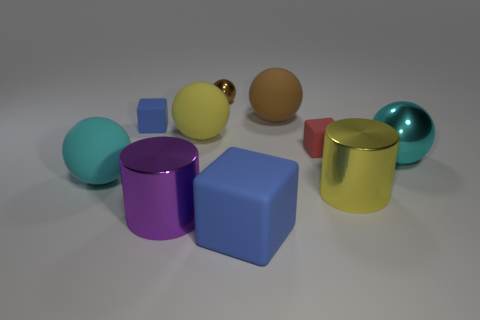There is a cyan object that is right of the cyan ball that is on the left side of the big yellow cylinder; how many cyan balls are to the left of it?
Ensure brevity in your answer.  1. There is a matte block that is in front of the big cyan rubber object; what color is it?
Ensure brevity in your answer.  Blue. There is a blue matte object that is behind the cylinder that is in front of the yellow cylinder; what is its shape?
Keep it short and to the point. Cube. Is the color of the big matte cube the same as the small shiny thing?
Provide a succinct answer. No. How many cylinders are either cyan rubber things or large cyan metal objects?
Ensure brevity in your answer.  0. What is the object that is both left of the big brown thing and behind the tiny blue rubber thing made of?
Keep it short and to the point. Metal. There is a tiny blue matte object; how many spheres are in front of it?
Provide a short and direct response. 3. Do the blue object that is behind the small red thing and the yellow object that is right of the big yellow rubber thing have the same material?
Provide a short and direct response. No. What number of objects are small rubber objects on the left side of the big cyan metallic thing or large brown rubber spheres?
Provide a succinct answer. 3. Is the number of large brown matte things that are in front of the big brown ball less than the number of big matte balls to the right of the large yellow rubber ball?
Offer a terse response. Yes. 